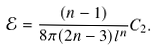Convert formula to latex. <formula><loc_0><loc_0><loc_500><loc_500>\mathcal { E } = \frac { ( n - 1 ) } { 8 \pi ( 2 n - 3 ) l ^ { n } } C _ { 2 } .</formula> 